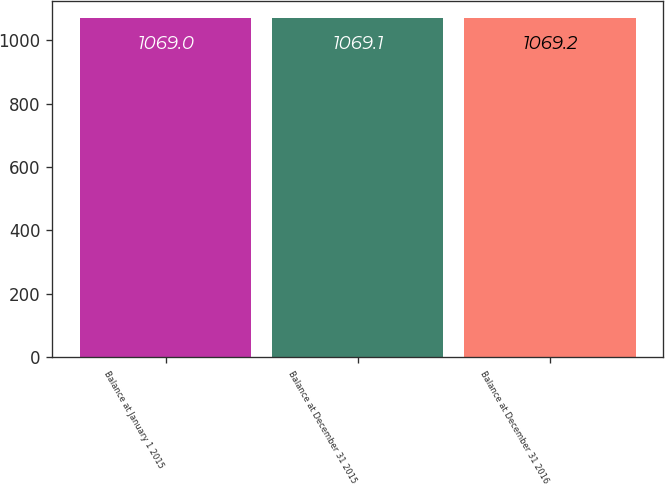Convert chart to OTSL. <chart><loc_0><loc_0><loc_500><loc_500><bar_chart><fcel>Balance at January 1 2015<fcel>Balance at December 31 2015<fcel>Balance at December 31 2016<nl><fcel>1069<fcel>1069.1<fcel>1069.2<nl></chart> 